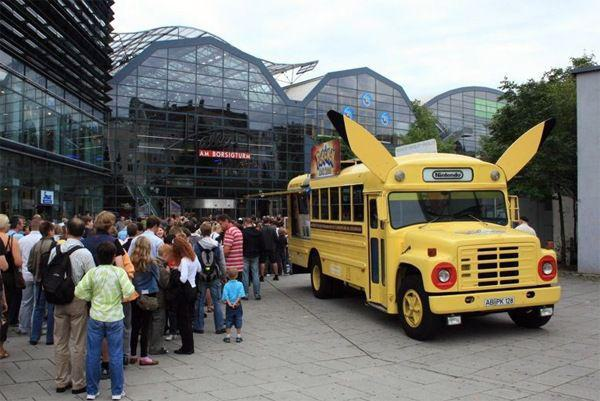How many unicorns would there be in the image after no additional unicorn was added in the image? 0 